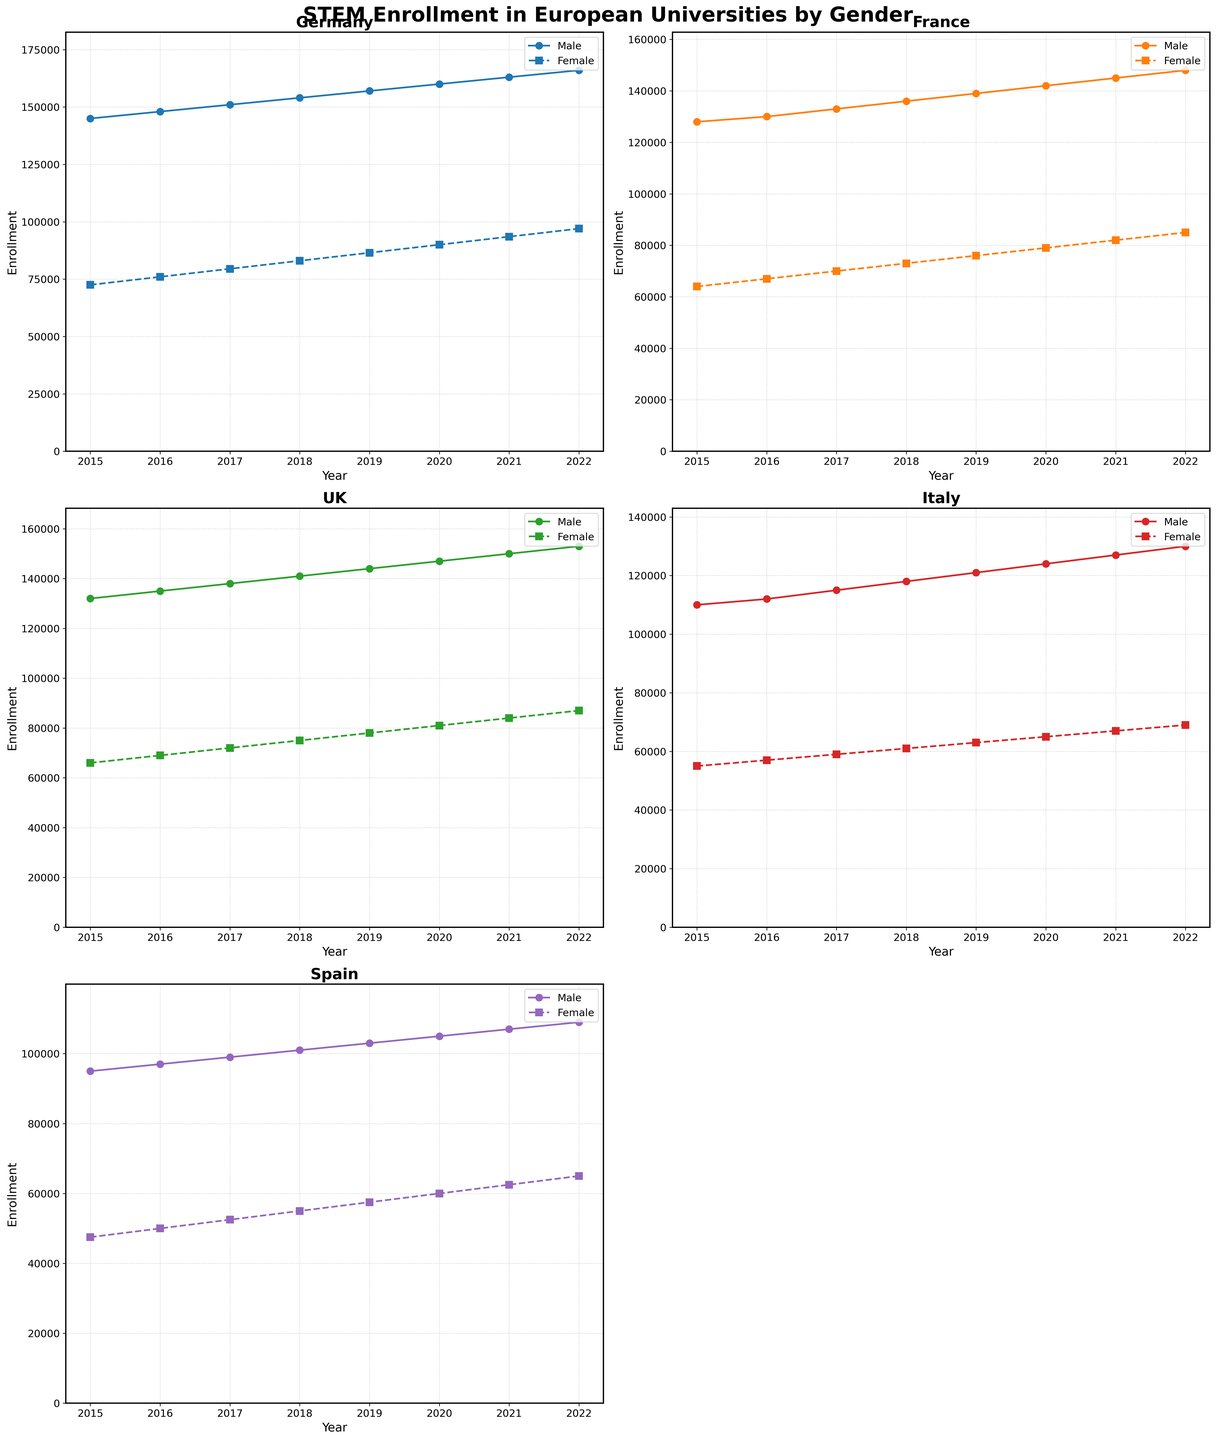What is the title of the figure? The title is typically located at the top of the figure and in this case, it should clearly reflect the content being displayed.
Answer: STEM Enrollment in European Universities by Gender Which country's STEM enrollment shows the smallest gender gap in 2022? To find the smallest gender gap, subtract the number of females from the number of males for each country in 2022 and compare.
Answer: UK How does the enrollment trend for males in Germany compare to that of females from 2015 to 2022? To compare the trends, observe how the enrollment numbers for males and females in Germany have changed over the period. Both trends show an increase, but the male enrollment is consistently higher.
Answer: Increasing for both By how much did female enrollment increase in Spain from 2015 to 2022? Subtract the enrollment number for females in 2015 from that in 2022 for Spain. \( 65000 - 47500 = 17500 \)
Answer: 17500 Which country had the highest STEM enrollment for females in 2020? Check the female enrollment data for all countries in 2020 and identify the highest value.
Answer: Germany What is the total enrollment for males and females combined in Italy in 2021? Add male and female enrollment numbers for Italy in 2021. \( 127000 + 67000 = 194000 \)
Answer: 194000 Between France and Spain, which country saw a higher growth in female enrollment from 2015 to 2022? Calculate the difference in female enrollment from 2015 to 2022 for both countries and compare. \( 85000 - 64000 = 21000 \) for France, \( 65000 - 47500 = 17500 \) for Spain.
Answer: France How does the enrollment growth rate for males in the UK from 2015 to 2022 compare to that in France? Calculate the growth rate as (enrollment in 2022 - enrollment in 2015) / enrollment in 2015 for both countries. \( (153000 - 132000) / 132000 \approx 0.159 \) for UK, \( (148000 - 128000) / 128000 \approx 0.156 \) for France. The UK has a slightly higher growth rate.
Answer: UK higher What is the average STEM enrollment for females in Germany over the given period? Sum the female enrollment figures for Germany from 2015 to 2022 and divide by the number of years. \((72500 + 76000 + 79500 + 83000 + 86500 + 90000 + 93500 + 97000) / 8 = 84750\)
Answer: 84750 